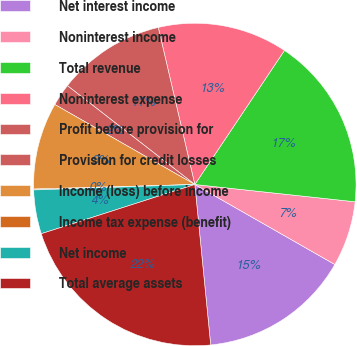Convert chart to OTSL. <chart><loc_0><loc_0><loc_500><loc_500><pie_chart><fcel>Net interest income<fcel>Noninterest income<fcel>Total revenue<fcel>Noninterest expense<fcel>Profit before provision for<fcel>Provision for credit losses<fcel>Income (loss) before income<fcel>Income tax expense (benefit)<fcel>Net income<fcel>Total average assets<nl><fcel>15.17%<fcel>6.55%<fcel>17.33%<fcel>13.02%<fcel>10.86%<fcel>2.24%<fcel>8.71%<fcel>0.09%<fcel>4.4%<fcel>21.63%<nl></chart> 